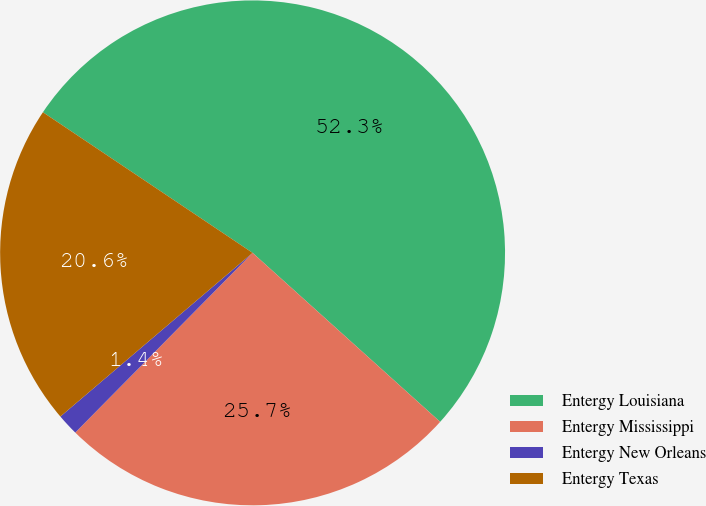Convert chart to OTSL. <chart><loc_0><loc_0><loc_500><loc_500><pie_chart><fcel>Entergy Louisiana<fcel>Entergy Mississippi<fcel>Entergy New Orleans<fcel>Entergy Texas<nl><fcel>52.27%<fcel>25.72%<fcel>1.38%<fcel>20.63%<nl></chart> 